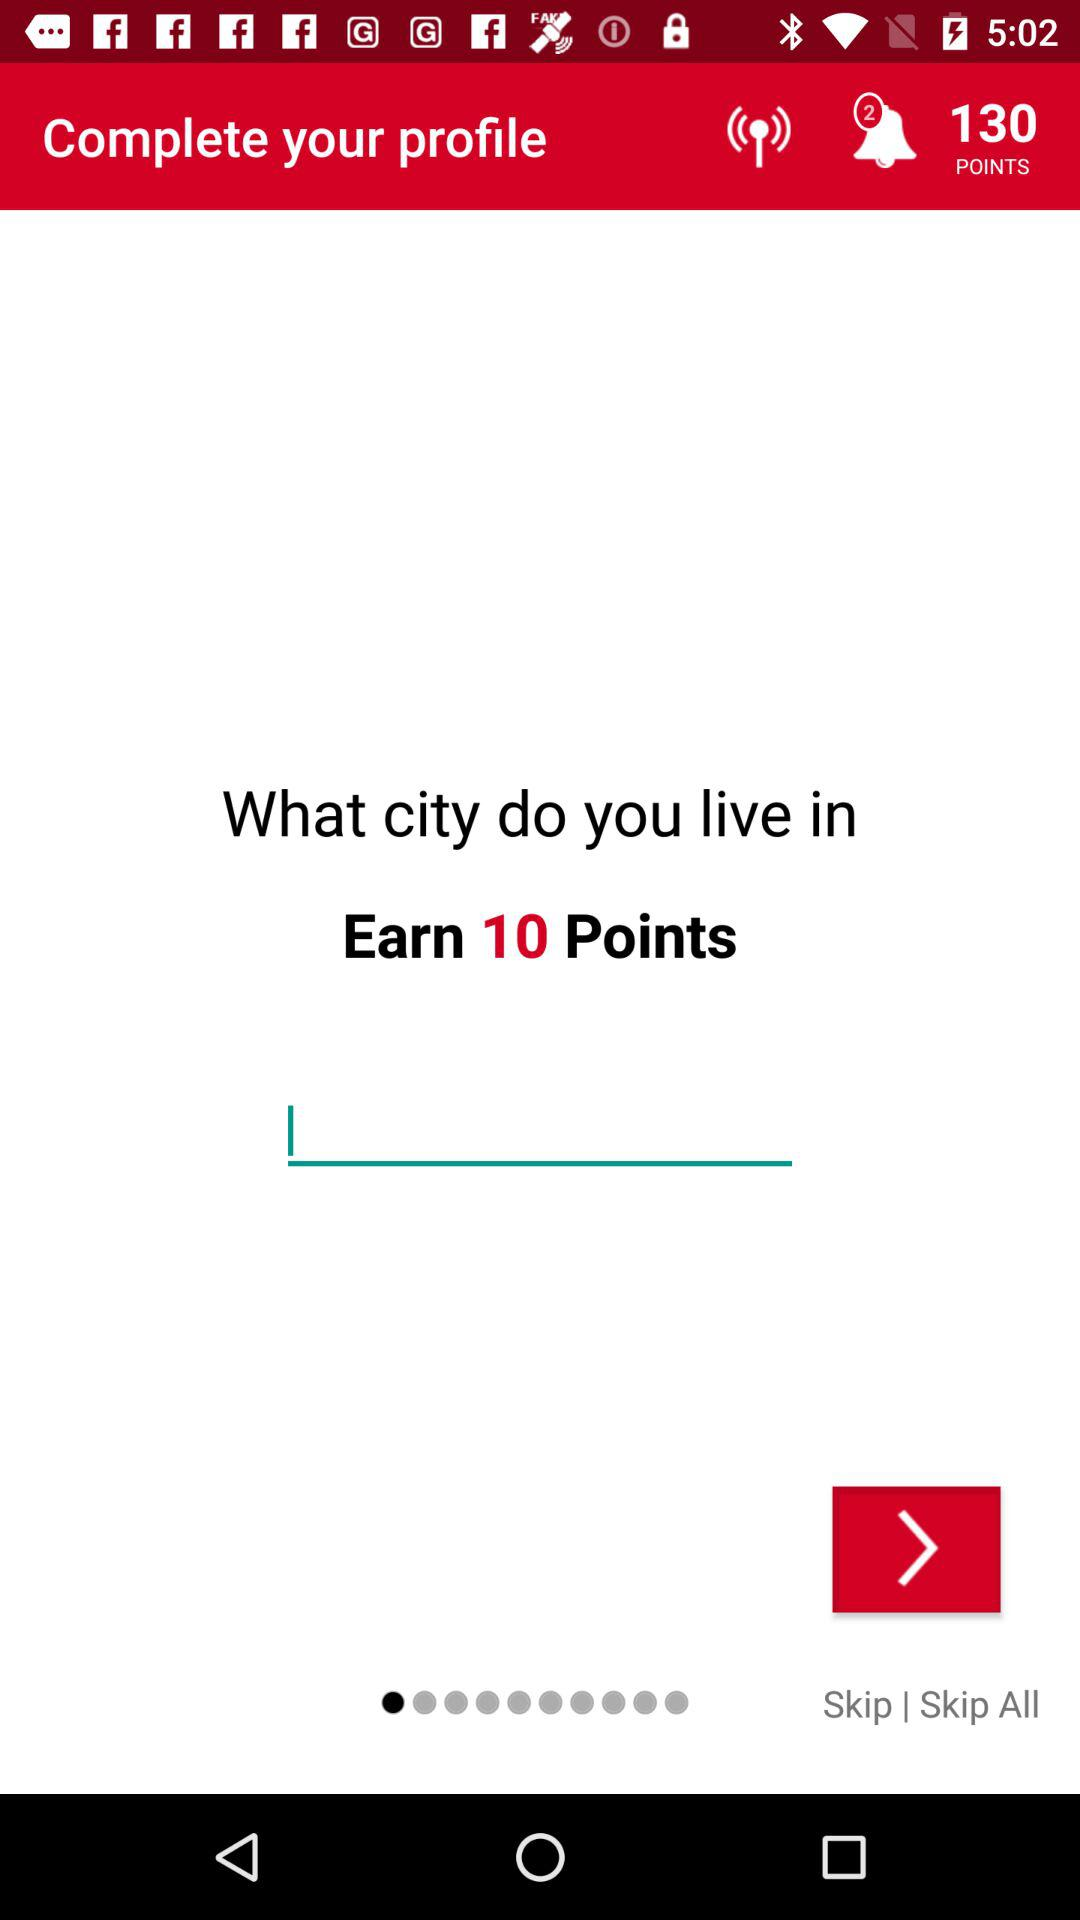Which city is entered?
When the provided information is insufficient, respond with <no answer>. <no answer> 